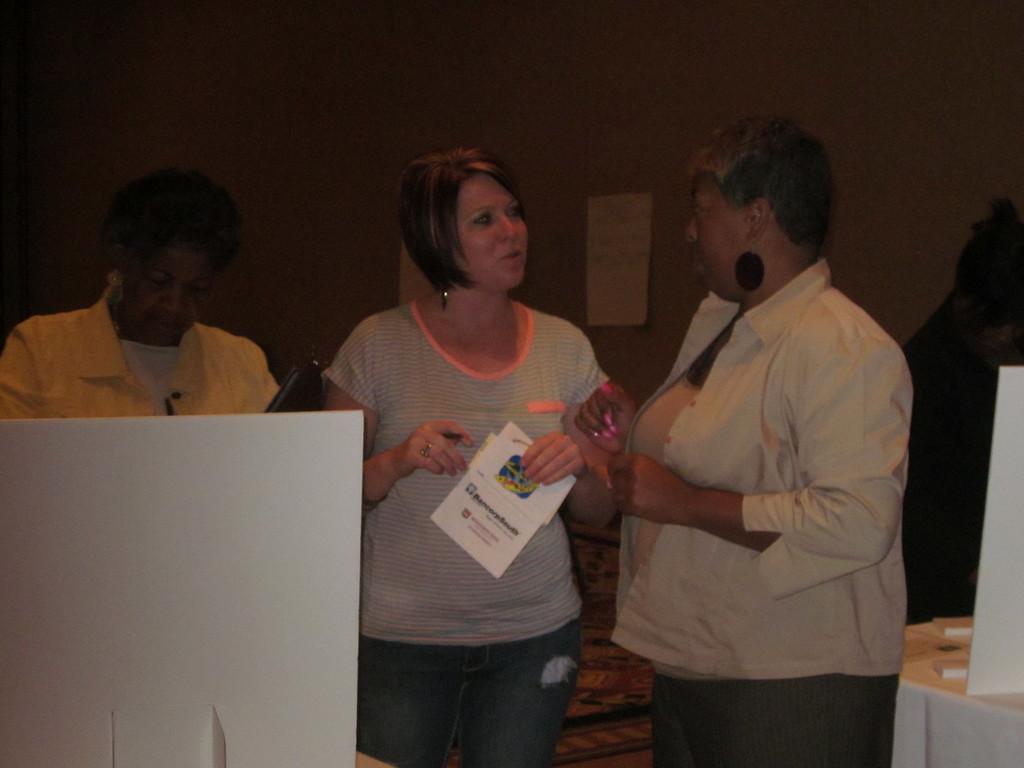How would you summarize this image in a sentence or two? In this picture we can see three persons are standing, a woman in the middle is holding papers, in the background there is a wall, we can see a paper pasted on the wall, a woman on the left side is holding something. 